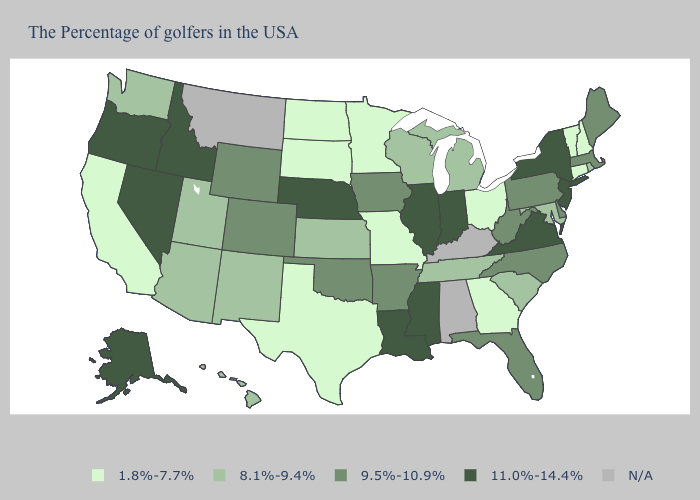Name the states that have a value in the range N/A?
Give a very brief answer. Kentucky, Alabama, Montana. Does New York have the highest value in the USA?
Concise answer only. Yes. Which states hav the highest value in the South?
Write a very short answer. Virginia, Mississippi, Louisiana. What is the value of New Mexico?
Answer briefly. 8.1%-9.4%. What is the value of Arizona?
Short answer required. 8.1%-9.4%. What is the value of Washington?
Concise answer only. 8.1%-9.4%. Which states have the highest value in the USA?
Be succinct. New York, New Jersey, Virginia, Indiana, Illinois, Mississippi, Louisiana, Nebraska, Idaho, Nevada, Oregon, Alaska. How many symbols are there in the legend?
Quick response, please. 5. Does New Jersey have the lowest value in the USA?
Be succinct. No. Name the states that have a value in the range 8.1%-9.4%?
Quick response, please. Rhode Island, Maryland, South Carolina, Michigan, Tennessee, Wisconsin, Kansas, New Mexico, Utah, Arizona, Washington, Hawaii. Name the states that have a value in the range 11.0%-14.4%?
Be succinct. New York, New Jersey, Virginia, Indiana, Illinois, Mississippi, Louisiana, Nebraska, Idaho, Nevada, Oregon, Alaska. Which states have the highest value in the USA?
Write a very short answer. New York, New Jersey, Virginia, Indiana, Illinois, Mississippi, Louisiana, Nebraska, Idaho, Nevada, Oregon, Alaska. What is the lowest value in the MidWest?
Give a very brief answer. 1.8%-7.7%. What is the lowest value in the USA?
Answer briefly. 1.8%-7.7%. 